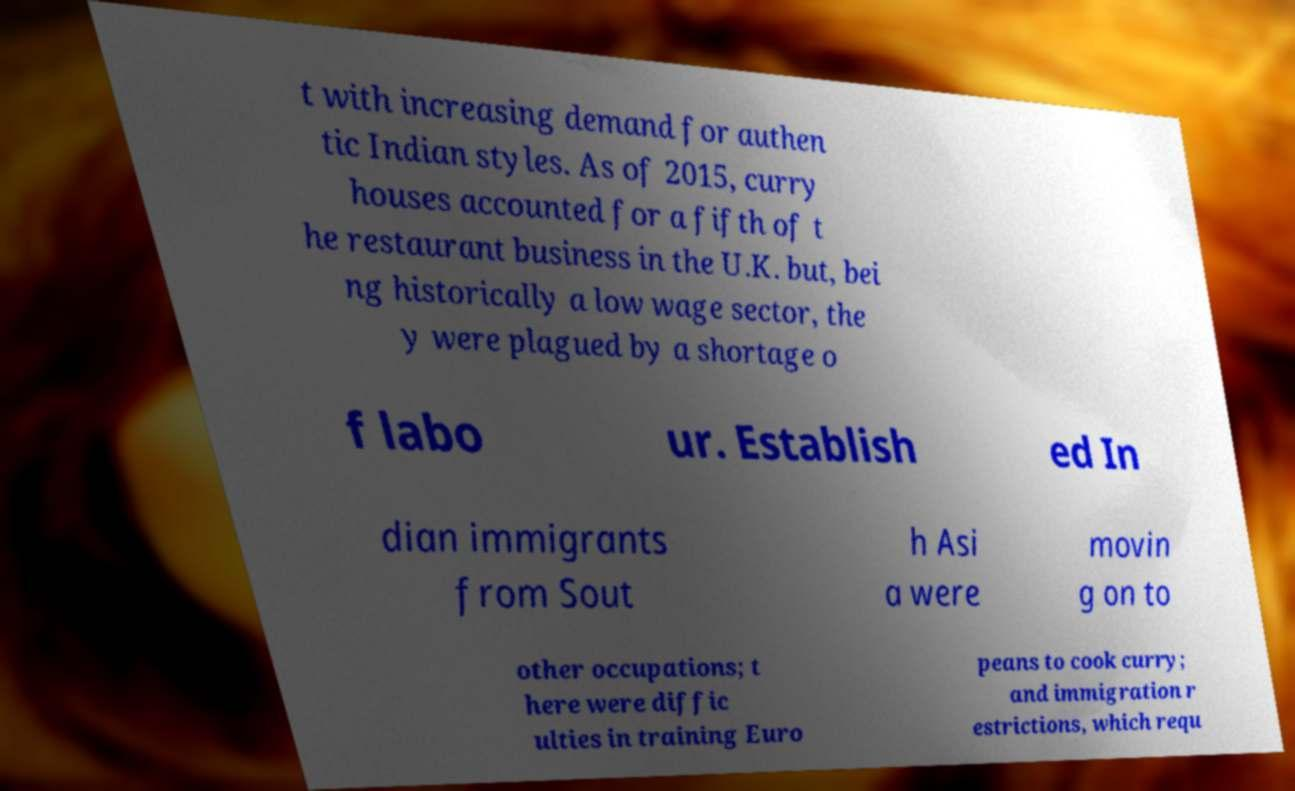Can you read and provide the text displayed in the image?This photo seems to have some interesting text. Can you extract and type it out for me? t with increasing demand for authen tic Indian styles. As of 2015, curry houses accounted for a fifth of t he restaurant business in the U.K. but, bei ng historically a low wage sector, the y were plagued by a shortage o f labo ur. Establish ed In dian immigrants from Sout h Asi a were movin g on to other occupations; t here were diffic ulties in training Euro peans to cook curry; and immigration r estrictions, which requ 